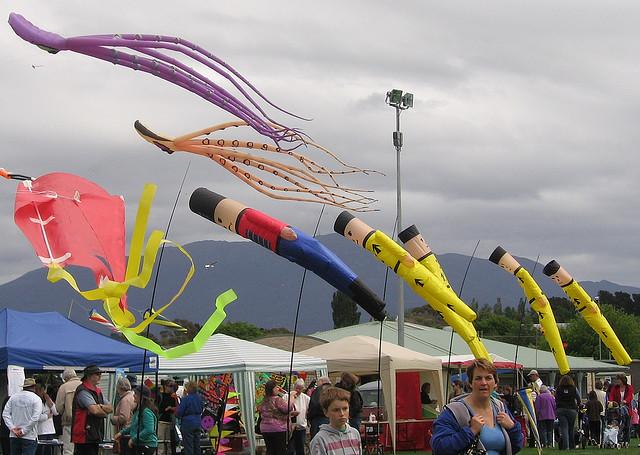Is it a windy day?
Be succinct. Yes. Where are the people?
Give a very brief answer. At fair. How many of the kites are identical?
Give a very brief answer. 4. How is the sky?
Be succinct. Cloudy. 